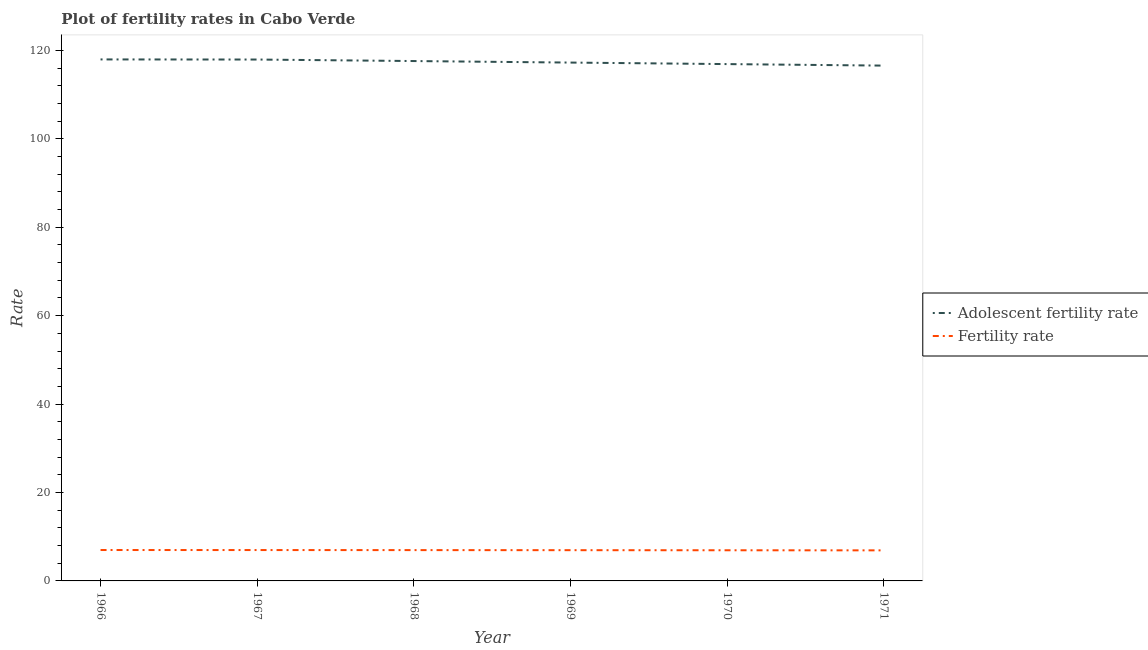How many different coloured lines are there?
Your response must be concise. 2. Is the number of lines equal to the number of legend labels?
Keep it short and to the point. Yes. What is the adolescent fertility rate in 1968?
Your answer should be very brief. 117.58. Across all years, what is the maximum fertility rate?
Provide a short and direct response. 6.99. Across all years, what is the minimum adolescent fertility rate?
Your answer should be very brief. 116.55. In which year was the fertility rate maximum?
Make the answer very short. 1966. What is the total adolescent fertility rate in the graph?
Give a very brief answer. 704.14. What is the difference between the adolescent fertility rate in 1966 and that in 1969?
Give a very brief answer. 0.71. What is the difference between the adolescent fertility rate in 1966 and the fertility rate in 1970?
Your answer should be compact. 111.02. What is the average adolescent fertility rate per year?
Make the answer very short. 117.36. In the year 1966, what is the difference between the adolescent fertility rate and fertility rate?
Make the answer very short. 110.96. What is the ratio of the fertility rate in 1966 to that in 1970?
Keep it short and to the point. 1.01. Is the adolescent fertility rate in 1969 less than that in 1971?
Ensure brevity in your answer.  No. Is the difference between the fertility rate in 1968 and 1969 greater than the difference between the adolescent fertility rate in 1968 and 1969?
Make the answer very short. No. What is the difference between the highest and the second highest fertility rate?
Your answer should be compact. 0.01. What is the difference between the highest and the lowest fertility rate?
Give a very brief answer. 0.08. In how many years, is the adolescent fertility rate greater than the average adolescent fertility rate taken over all years?
Provide a short and direct response. 3. What is the difference between two consecutive major ticks on the Y-axis?
Provide a short and direct response. 20. Are the values on the major ticks of Y-axis written in scientific E-notation?
Provide a succinct answer. No. Does the graph contain any zero values?
Make the answer very short. No. Does the graph contain grids?
Your answer should be very brief. No. How many legend labels are there?
Your answer should be very brief. 2. What is the title of the graph?
Give a very brief answer. Plot of fertility rates in Cabo Verde. What is the label or title of the X-axis?
Offer a terse response. Year. What is the label or title of the Y-axis?
Provide a short and direct response. Rate. What is the Rate of Adolescent fertility rate in 1966?
Provide a short and direct response. 117.95. What is the Rate of Fertility rate in 1966?
Provide a short and direct response. 6.99. What is the Rate of Adolescent fertility rate in 1967?
Your answer should be compact. 117.92. What is the Rate in Fertility rate in 1967?
Ensure brevity in your answer.  6.98. What is the Rate in Adolescent fertility rate in 1968?
Your answer should be very brief. 117.58. What is the Rate in Fertility rate in 1968?
Provide a succinct answer. 6.97. What is the Rate in Adolescent fertility rate in 1969?
Your answer should be very brief. 117.24. What is the Rate of Fertility rate in 1969?
Make the answer very short. 6.95. What is the Rate of Adolescent fertility rate in 1970?
Keep it short and to the point. 116.89. What is the Rate of Fertility rate in 1970?
Keep it short and to the point. 6.93. What is the Rate in Adolescent fertility rate in 1971?
Offer a very short reply. 116.55. What is the Rate in Fertility rate in 1971?
Your answer should be compact. 6.91. Across all years, what is the maximum Rate of Adolescent fertility rate?
Your answer should be compact. 117.95. Across all years, what is the maximum Rate in Fertility rate?
Provide a succinct answer. 6.99. Across all years, what is the minimum Rate of Adolescent fertility rate?
Your response must be concise. 116.55. Across all years, what is the minimum Rate of Fertility rate?
Provide a succinct answer. 6.91. What is the total Rate of Adolescent fertility rate in the graph?
Provide a short and direct response. 704.14. What is the total Rate in Fertility rate in the graph?
Your response must be concise. 41.74. What is the difference between the Rate of Adolescent fertility rate in 1966 and that in 1967?
Make the answer very short. 0.03. What is the difference between the Rate of Fertility rate in 1966 and that in 1967?
Give a very brief answer. 0.01. What is the difference between the Rate in Adolescent fertility rate in 1966 and that in 1968?
Keep it short and to the point. 0.37. What is the difference between the Rate in Fertility rate in 1966 and that in 1968?
Offer a terse response. 0.02. What is the difference between the Rate of Adolescent fertility rate in 1966 and that in 1969?
Keep it short and to the point. 0.71. What is the difference between the Rate in Fertility rate in 1966 and that in 1969?
Keep it short and to the point. 0.04. What is the difference between the Rate in Adolescent fertility rate in 1966 and that in 1970?
Provide a short and direct response. 1.06. What is the difference between the Rate in Fertility rate in 1966 and that in 1970?
Offer a terse response. 0.06. What is the difference between the Rate in Adolescent fertility rate in 1966 and that in 1971?
Your answer should be very brief. 1.4. What is the difference between the Rate in Fertility rate in 1966 and that in 1971?
Provide a short and direct response. 0.08. What is the difference between the Rate of Adolescent fertility rate in 1967 and that in 1968?
Make the answer very short. 0.34. What is the difference between the Rate in Fertility rate in 1967 and that in 1968?
Ensure brevity in your answer.  0.01. What is the difference between the Rate in Adolescent fertility rate in 1967 and that in 1969?
Give a very brief answer. 0.69. What is the difference between the Rate of Fertility rate in 1967 and that in 1969?
Give a very brief answer. 0.03. What is the difference between the Rate of Adolescent fertility rate in 1967 and that in 1970?
Make the answer very short. 1.03. What is the difference between the Rate in Fertility rate in 1967 and that in 1970?
Ensure brevity in your answer.  0.05. What is the difference between the Rate in Adolescent fertility rate in 1967 and that in 1971?
Provide a short and direct response. 1.37. What is the difference between the Rate in Fertility rate in 1967 and that in 1971?
Make the answer very short. 0.07. What is the difference between the Rate in Adolescent fertility rate in 1968 and that in 1969?
Offer a terse response. 0.34. What is the difference between the Rate in Fertility rate in 1968 and that in 1969?
Provide a short and direct response. 0.02. What is the difference between the Rate of Adolescent fertility rate in 1968 and that in 1970?
Your response must be concise. 0.69. What is the difference between the Rate in Fertility rate in 1968 and that in 1970?
Your answer should be compact. 0.04. What is the difference between the Rate in Adolescent fertility rate in 1968 and that in 1971?
Offer a very short reply. 1.03. What is the difference between the Rate of Fertility rate in 1968 and that in 1971?
Give a very brief answer. 0.06. What is the difference between the Rate in Adolescent fertility rate in 1969 and that in 1970?
Your answer should be very brief. 0.34. What is the difference between the Rate of Fertility rate in 1969 and that in 1970?
Keep it short and to the point. 0.02. What is the difference between the Rate in Adolescent fertility rate in 1969 and that in 1971?
Offer a very short reply. 0.69. What is the difference between the Rate in Fertility rate in 1969 and that in 1971?
Ensure brevity in your answer.  0.04. What is the difference between the Rate of Adolescent fertility rate in 1970 and that in 1971?
Ensure brevity in your answer.  0.34. What is the difference between the Rate of Fertility rate in 1970 and that in 1971?
Make the answer very short. 0.02. What is the difference between the Rate of Adolescent fertility rate in 1966 and the Rate of Fertility rate in 1967?
Give a very brief answer. 110.97. What is the difference between the Rate in Adolescent fertility rate in 1966 and the Rate in Fertility rate in 1968?
Keep it short and to the point. 110.98. What is the difference between the Rate of Adolescent fertility rate in 1966 and the Rate of Fertility rate in 1969?
Make the answer very short. 111. What is the difference between the Rate of Adolescent fertility rate in 1966 and the Rate of Fertility rate in 1970?
Keep it short and to the point. 111.02. What is the difference between the Rate of Adolescent fertility rate in 1966 and the Rate of Fertility rate in 1971?
Make the answer very short. 111.04. What is the difference between the Rate of Adolescent fertility rate in 1967 and the Rate of Fertility rate in 1968?
Ensure brevity in your answer.  110.95. What is the difference between the Rate of Adolescent fertility rate in 1967 and the Rate of Fertility rate in 1969?
Make the answer very short. 110.97. What is the difference between the Rate of Adolescent fertility rate in 1967 and the Rate of Fertility rate in 1970?
Provide a succinct answer. 110.99. What is the difference between the Rate in Adolescent fertility rate in 1967 and the Rate in Fertility rate in 1971?
Your answer should be very brief. 111.01. What is the difference between the Rate in Adolescent fertility rate in 1968 and the Rate in Fertility rate in 1969?
Offer a very short reply. 110.63. What is the difference between the Rate of Adolescent fertility rate in 1968 and the Rate of Fertility rate in 1970?
Ensure brevity in your answer.  110.65. What is the difference between the Rate of Adolescent fertility rate in 1968 and the Rate of Fertility rate in 1971?
Your response must be concise. 110.67. What is the difference between the Rate of Adolescent fertility rate in 1969 and the Rate of Fertility rate in 1970?
Keep it short and to the point. 110.3. What is the difference between the Rate of Adolescent fertility rate in 1969 and the Rate of Fertility rate in 1971?
Your response must be concise. 110.32. What is the difference between the Rate of Adolescent fertility rate in 1970 and the Rate of Fertility rate in 1971?
Your response must be concise. 109.98. What is the average Rate of Adolescent fertility rate per year?
Your answer should be very brief. 117.36. What is the average Rate of Fertility rate per year?
Offer a terse response. 6.96. In the year 1966, what is the difference between the Rate in Adolescent fertility rate and Rate in Fertility rate?
Offer a very short reply. 110.96. In the year 1967, what is the difference between the Rate of Adolescent fertility rate and Rate of Fertility rate?
Your answer should be compact. 110.94. In the year 1968, what is the difference between the Rate in Adolescent fertility rate and Rate in Fertility rate?
Keep it short and to the point. 110.61. In the year 1969, what is the difference between the Rate of Adolescent fertility rate and Rate of Fertility rate?
Your response must be concise. 110.28. In the year 1970, what is the difference between the Rate in Adolescent fertility rate and Rate in Fertility rate?
Provide a succinct answer. 109.96. In the year 1971, what is the difference between the Rate in Adolescent fertility rate and Rate in Fertility rate?
Make the answer very short. 109.64. What is the ratio of the Rate in Adolescent fertility rate in 1966 to that in 1967?
Ensure brevity in your answer.  1. What is the ratio of the Rate of Adolescent fertility rate in 1966 to that in 1968?
Your response must be concise. 1. What is the ratio of the Rate of Adolescent fertility rate in 1966 to that in 1969?
Ensure brevity in your answer.  1.01. What is the ratio of the Rate in Adolescent fertility rate in 1966 to that in 1970?
Make the answer very short. 1.01. What is the ratio of the Rate of Fertility rate in 1966 to that in 1970?
Give a very brief answer. 1.01. What is the ratio of the Rate of Fertility rate in 1966 to that in 1971?
Your response must be concise. 1.01. What is the ratio of the Rate of Adolescent fertility rate in 1967 to that in 1968?
Offer a very short reply. 1. What is the ratio of the Rate in Adolescent fertility rate in 1967 to that in 1969?
Your answer should be compact. 1.01. What is the ratio of the Rate of Adolescent fertility rate in 1967 to that in 1970?
Keep it short and to the point. 1.01. What is the ratio of the Rate in Fertility rate in 1967 to that in 1970?
Your answer should be compact. 1.01. What is the ratio of the Rate of Adolescent fertility rate in 1967 to that in 1971?
Provide a succinct answer. 1.01. What is the ratio of the Rate in Fertility rate in 1967 to that in 1971?
Make the answer very short. 1.01. What is the ratio of the Rate in Fertility rate in 1968 to that in 1969?
Your answer should be very brief. 1. What is the ratio of the Rate in Adolescent fertility rate in 1968 to that in 1970?
Provide a short and direct response. 1.01. What is the ratio of the Rate in Adolescent fertility rate in 1968 to that in 1971?
Your answer should be compact. 1.01. What is the ratio of the Rate in Fertility rate in 1968 to that in 1971?
Offer a very short reply. 1.01. What is the ratio of the Rate in Fertility rate in 1969 to that in 1970?
Ensure brevity in your answer.  1. What is the ratio of the Rate in Adolescent fertility rate in 1969 to that in 1971?
Give a very brief answer. 1.01. What is the ratio of the Rate of Fertility rate in 1969 to that in 1971?
Make the answer very short. 1.01. What is the ratio of the Rate in Adolescent fertility rate in 1970 to that in 1971?
Ensure brevity in your answer.  1. What is the ratio of the Rate of Fertility rate in 1970 to that in 1971?
Give a very brief answer. 1. What is the difference between the highest and the second highest Rate of Adolescent fertility rate?
Provide a short and direct response. 0.03. What is the difference between the highest and the second highest Rate in Fertility rate?
Provide a succinct answer. 0.01. What is the difference between the highest and the lowest Rate of Adolescent fertility rate?
Ensure brevity in your answer.  1.4. What is the difference between the highest and the lowest Rate in Fertility rate?
Offer a terse response. 0.08. 